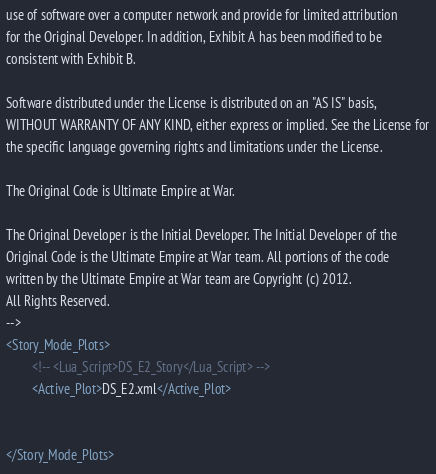Convert code to text. <code><loc_0><loc_0><loc_500><loc_500><_XML_>use of software over a computer network and provide for limited attribution
for the Original Developer. In addition, Exhibit A has been modified to be
consistent with Exhibit B.
    
Software distributed under the License is distributed on an "AS IS" basis,
WITHOUT WARRANTY OF ANY KIND, either express or implied. See the License for
the specific language governing rights and limitations under the License.
    
The Original Code is Ultimate Empire at War.
    
The Original Developer is the Initial Developer. The Initial Developer of the
Original Code is the Ultimate Empire at War team. All portions of the code
written by the Ultimate Empire at War team are Copyright (c) 2012.
All Rights Reserved.
-->
<Story_Mode_Plots>
        <!-- <Lua_Script>DS_E2_Story</Lua_Script> -->
        <Active_Plot>DS_E2.xml</Active_Plot>


</Story_Mode_Plots></code> 